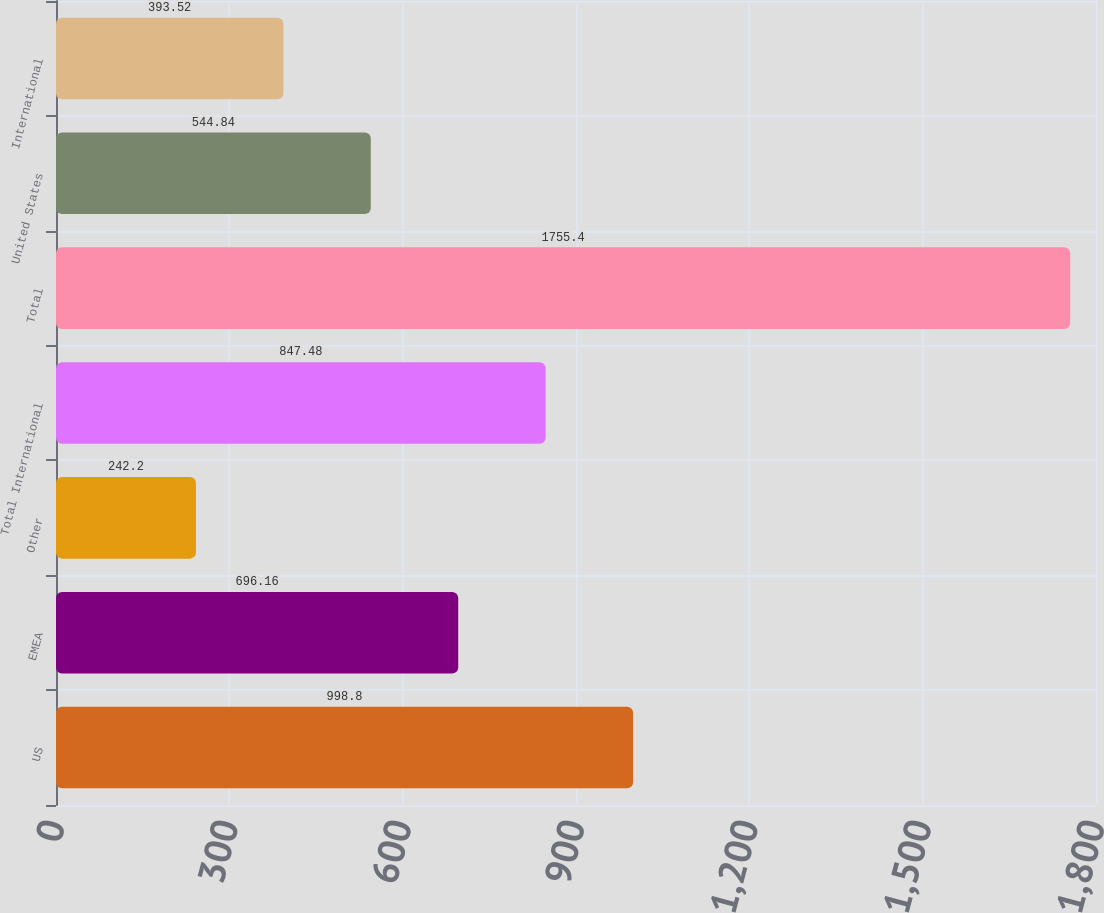<chart> <loc_0><loc_0><loc_500><loc_500><bar_chart><fcel>US<fcel>EMEA<fcel>Other<fcel>Total International<fcel>Total<fcel>United States<fcel>International<nl><fcel>998.8<fcel>696.16<fcel>242.2<fcel>847.48<fcel>1755.4<fcel>544.84<fcel>393.52<nl></chart> 